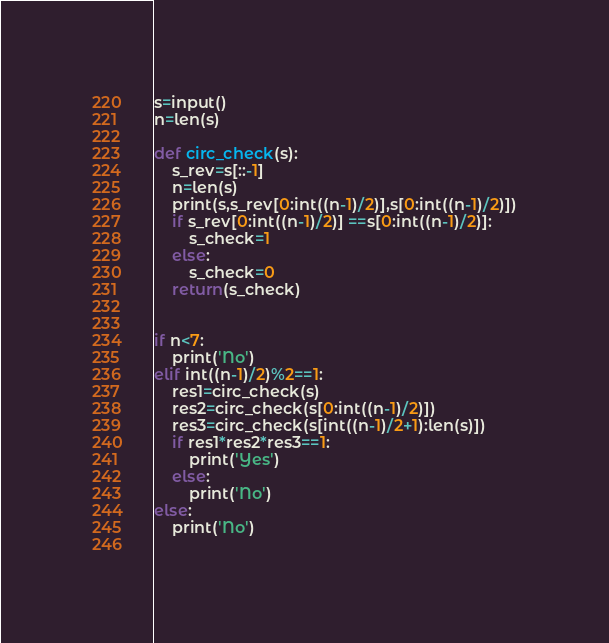<code> <loc_0><loc_0><loc_500><loc_500><_Python_>s=input()
n=len(s)

def circ_check(s):
    s_rev=s[::-1]
    n=len(s)
    print(s,s_rev[0:int((n-1)/2)],s[0:int((n-1)/2)])
    if s_rev[0:int((n-1)/2)] ==s[0:int((n-1)/2)]:
        s_check=1
    else:
        s_check=0
    return(s_check) 

  
if n<7:
    print('No')
elif int((n-1)/2)%2==1:
    res1=circ_check(s)
    res2=circ_check(s[0:int((n-1)/2)])
    res3=circ_check(s[int((n-1)/2+1):len(s)])
    if res1*res2*res3==1:
        print('Yes')
    else:
        print('No')
else:
    print('No')
  </code> 